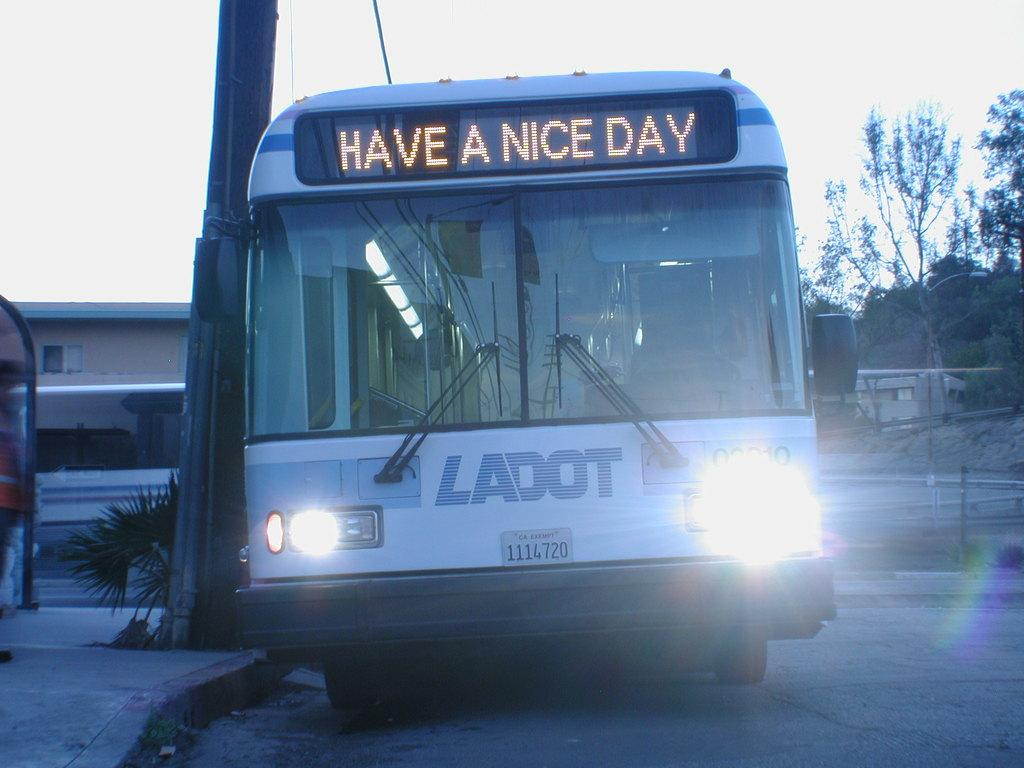<image>
Summarize the visual content of the image. A white bus has a sign on the front that reads, Have a Nice Day. 